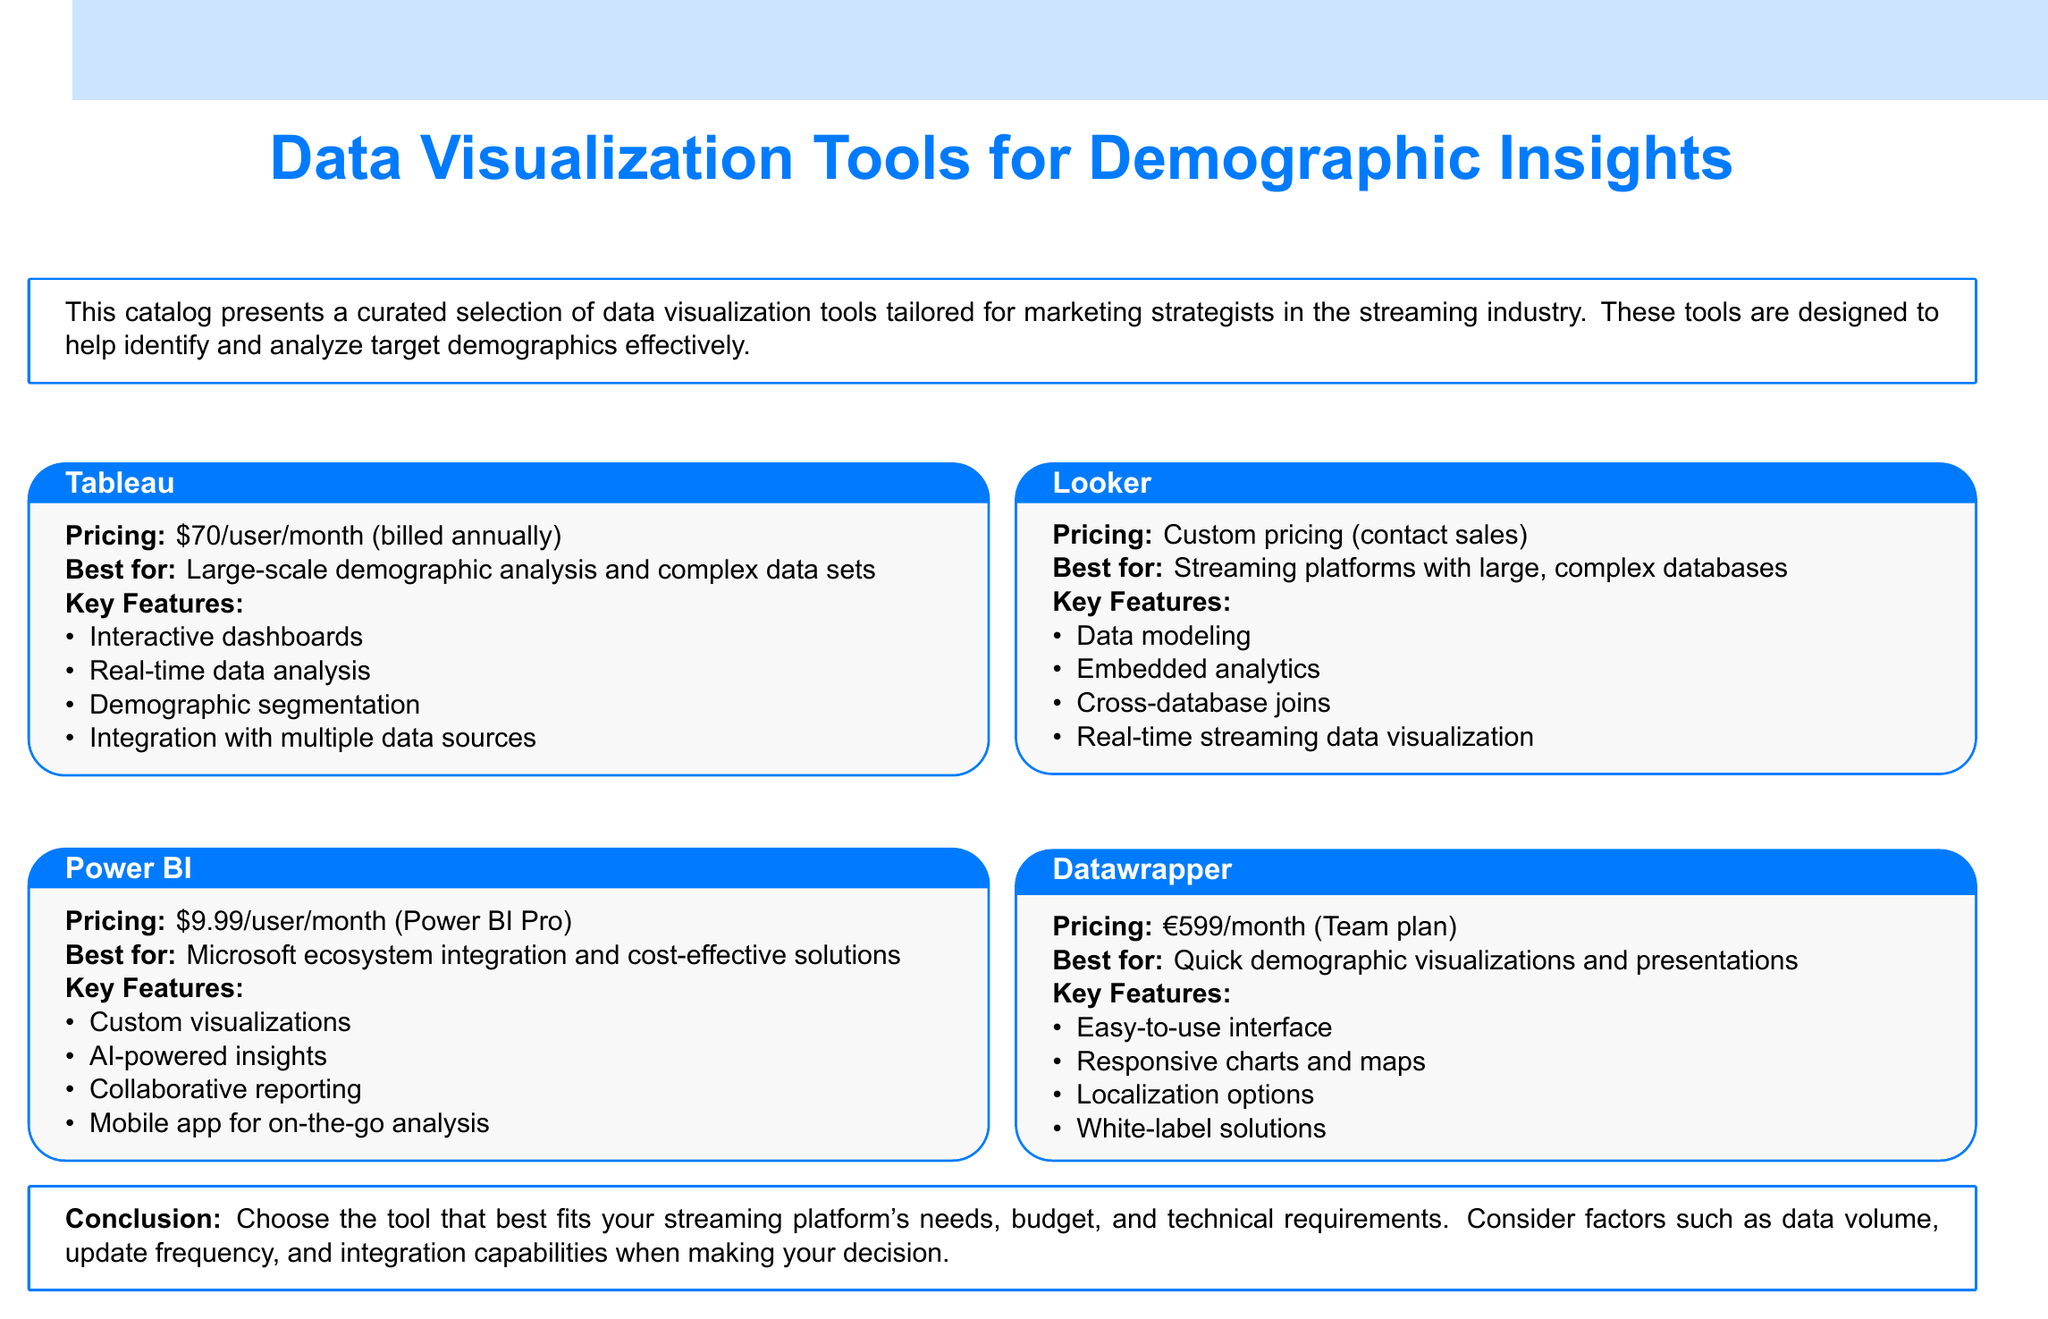What is the pricing for Tableau? The pricing for Tableau is \$70/user/month (billed annually).
Answer: \$70/user/month (billed annually) What is the best feature of Power BI? The best feature of Power BI is its integration with the Microsoft ecosystem.
Answer: Microsoft ecosystem integration What is the monthly cost for Datawrapper's Team plan? The monthly cost for Datawrapper's Team plan is €599.
Answer: €599 Which tool is best for large-scale demographic analysis? The tool best for large-scale demographic analysis is Tableau.
Answer: Tableau What is the pricing model for Looker? Looker's pricing model is custom pricing (contact sales).
Answer: Custom pricing (contact sales) Which tool offers AI-powered insights? The tool that offers AI-powered insights is Power BI.
Answer: Power BI What is the primary focus of Datawrapper? The primary focus of Datawrapper is quick demographic visualizations.
Answer: Quick demographic visualizations How many tools are listed in the document? The document lists four tools.
Answer: Four What do you need to consider when choosing a tool? You need to consider factors such as data volume and integration capabilities.
Answer: Data volume and integration capabilities 